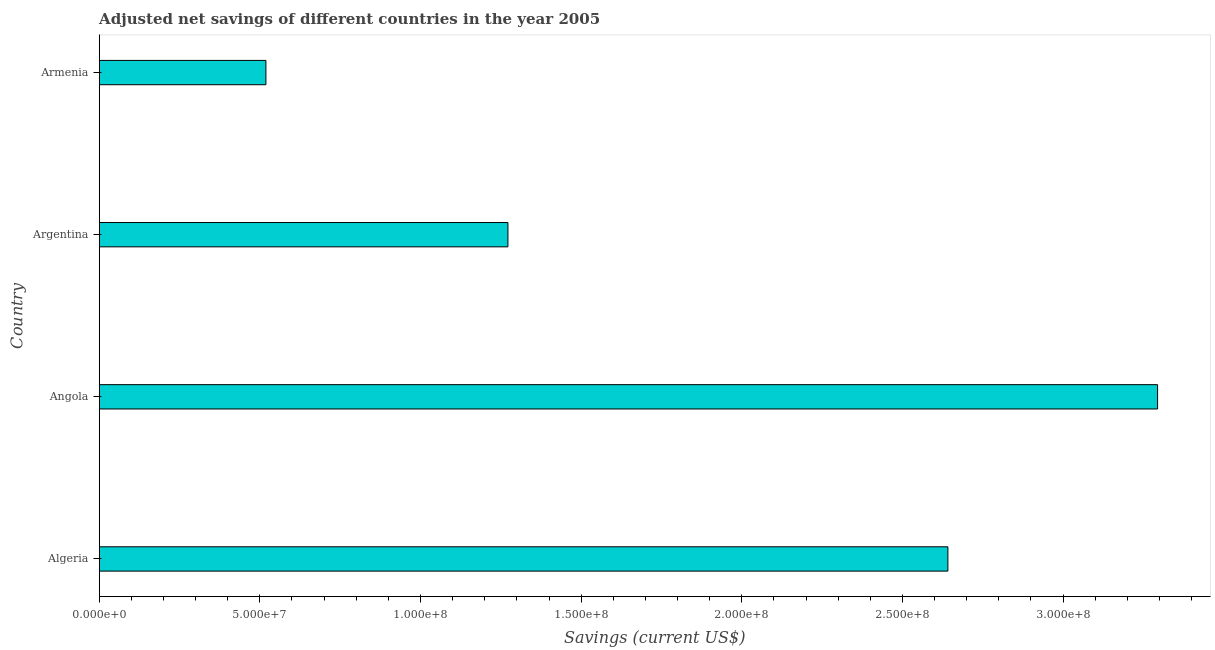Does the graph contain grids?
Give a very brief answer. No. What is the title of the graph?
Provide a succinct answer. Adjusted net savings of different countries in the year 2005. What is the label or title of the X-axis?
Provide a succinct answer. Savings (current US$). What is the adjusted net savings in Angola?
Your answer should be very brief. 3.29e+08. Across all countries, what is the maximum adjusted net savings?
Provide a short and direct response. 3.29e+08. Across all countries, what is the minimum adjusted net savings?
Your response must be concise. 5.19e+07. In which country was the adjusted net savings maximum?
Ensure brevity in your answer.  Angola. In which country was the adjusted net savings minimum?
Your answer should be very brief. Armenia. What is the sum of the adjusted net savings?
Offer a very short reply. 7.73e+08. What is the difference between the adjusted net savings in Angola and Armenia?
Make the answer very short. 2.78e+08. What is the average adjusted net savings per country?
Your answer should be compact. 1.93e+08. What is the median adjusted net savings?
Ensure brevity in your answer.  1.96e+08. In how many countries, is the adjusted net savings greater than 270000000 US$?
Give a very brief answer. 1. What is the ratio of the adjusted net savings in Angola to that in Argentina?
Provide a short and direct response. 2.59. Is the adjusted net savings in Algeria less than that in Armenia?
Give a very brief answer. No. Is the difference between the adjusted net savings in Algeria and Angola greater than the difference between any two countries?
Make the answer very short. No. What is the difference between the highest and the second highest adjusted net savings?
Your answer should be very brief. 6.53e+07. What is the difference between the highest and the lowest adjusted net savings?
Your answer should be very brief. 2.78e+08. In how many countries, is the adjusted net savings greater than the average adjusted net savings taken over all countries?
Keep it short and to the point. 2. How many bars are there?
Your answer should be compact. 4. How many countries are there in the graph?
Make the answer very short. 4. What is the difference between two consecutive major ticks on the X-axis?
Offer a terse response. 5.00e+07. Are the values on the major ticks of X-axis written in scientific E-notation?
Your response must be concise. Yes. What is the Savings (current US$) of Algeria?
Your answer should be very brief. 2.64e+08. What is the Savings (current US$) in Angola?
Your answer should be compact. 3.29e+08. What is the Savings (current US$) of Argentina?
Provide a short and direct response. 1.27e+08. What is the Savings (current US$) of Armenia?
Your answer should be compact. 5.19e+07. What is the difference between the Savings (current US$) in Algeria and Angola?
Offer a terse response. -6.53e+07. What is the difference between the Savings (current US$) in Algeria and Argentina?
Your answer should be compact. 1.37e+08. What is the difference between the Savings (current US$) in Algeria and Armenia?
Provide a succinct answer. 2.12e+08. What is the difference between the Savings (current US$) in Angola and Argentina?
Provide a succinct answer. 2.02e+08. What is the difference between the Savings (current US$) in Angola and Armenia?
Keep it short and to the point. 2.78e+08. What is the difference between the Savings (current US$) in Argentina and Armenia?
Offer a terse response. 7.53e+07. What is the ratio of the Savings (current US$) in Algeria to that in Angola?
Offer a terse response. 0.8. What is the ratio of the Savings (current US$) in Algeria to that in Argentina?
Ensure brevity in your answer.  2.08. What is the ratio of the Savings (current US$) in Algeria to that in Armenia?
Offer a very short reply. 5.09. What is the ratio of the Savings (current US$) in Angola to that in Argentina?
Your answer should be very brief. 2.59. What is the ratio of the Savings (current US$) in Angola to that in Armenia?
Offer a very short reply. 6.35. What is the ratio of the Savings (current US$) in Argentina to that in Armenia?
Provide a succinct answer. 2.45. 